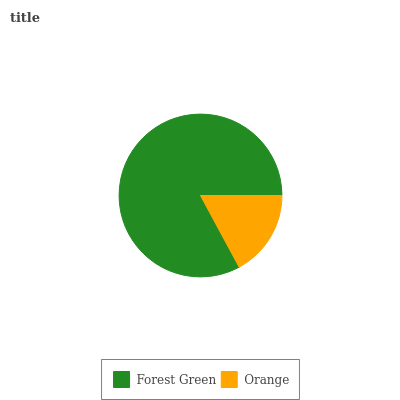Is Orange the minimum?
Answer yes or no. Yes. Is Forest Green the maximum?
Answer yes or no. Yes. Is Orange the maximum?
Answer yes or no. No. Is Forest Green greater than Orange?
Answer yes or no. Yes. Is Orange less than Forest Green?
Answer yes or no. Yes. Is Orange greater than Forest Green?
Answer yes or no. No. Is Forest Green less than Orange?
Answer yes or no. No. Is Forest Green the high median?
Answer yes or no. Yes. Is Orange the low median?
Answer yes or no. Yes. Is Orange the high median?
Answer yes or no. No. Is Forest Green the low median?
Answer yes or no. No. 